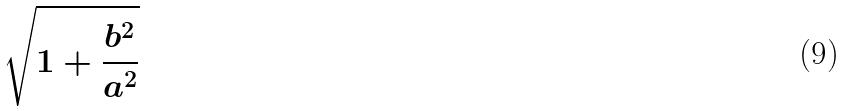Convert formula to latex. <formula><loc_0><loc_0><loc_500><loc_500>\sqrt { 1 + \frac { b ^ { 2 } } { a ^ { 2 } } }</formula> 